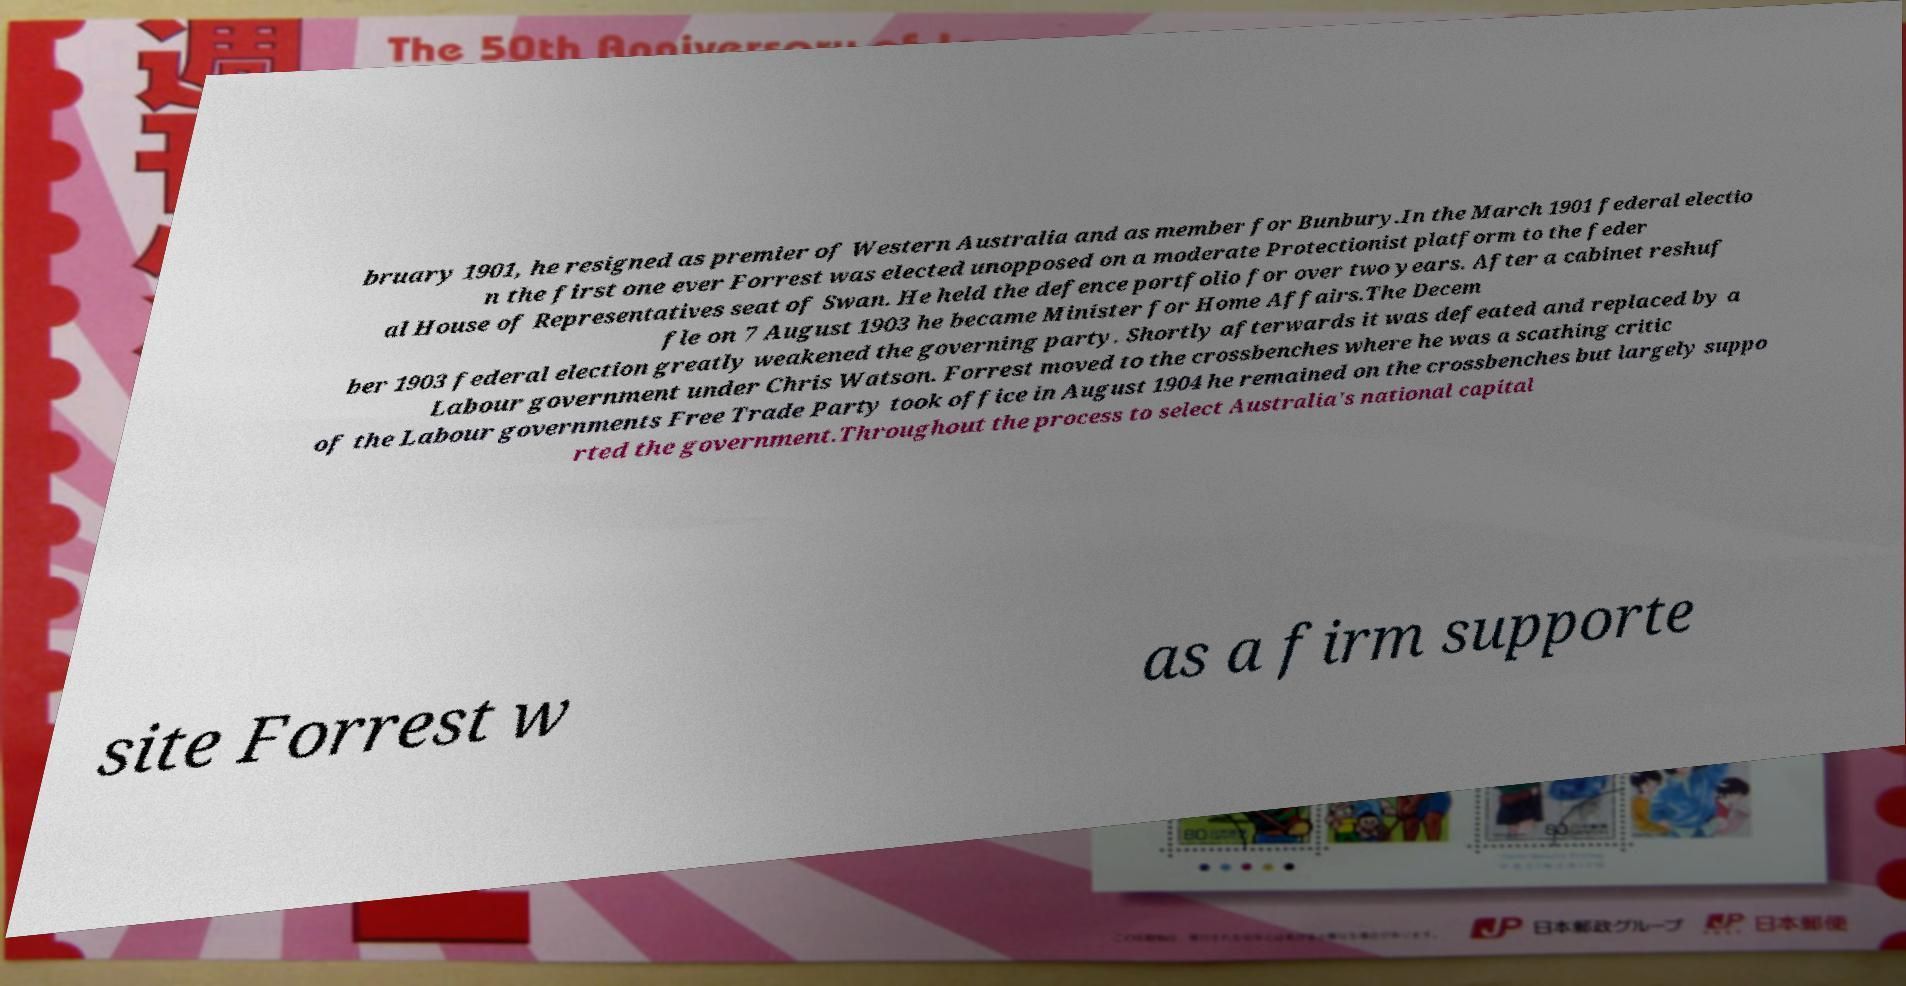Could you extract and type out the text from this image? bruary 1901, he resigned as premier of Western Australia and as member for Bunbury.In the March 1901 federal electio n the first one ever Forrest was elected unopposed on a moderate Protectionist platform to the feder al House of Representatives seat of Swan. He held the defence portfolio for over two years. After a cabinet reshuf fle on 7 August 1903 he became Minister for Home Affairs.The Decem ber 1903 federal election greatly weakened the governing party. Shortly afterwards it was defeated and replaced by a Labour government under Chris Watson. Forrest moved to the crossbenches where he was a scathing critic of the Labour governments Free Trade Party took office in August 1904 he remained on the crossbenches but largely suppo rted the government.Throughout the process to select Australia's national capital site Forrest w as a firm supporte 